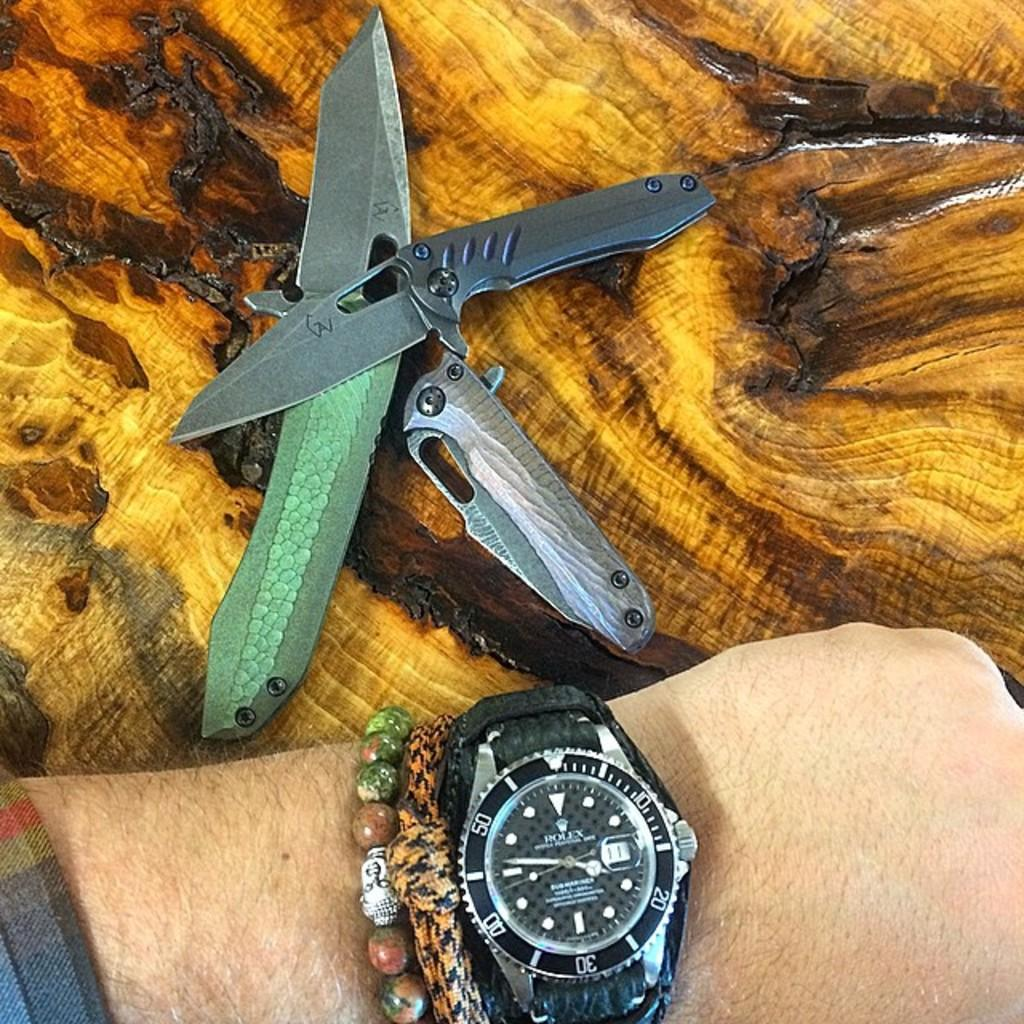<image>
Describe the image concisely. A person is wearing a Rolex watch with a black face. 